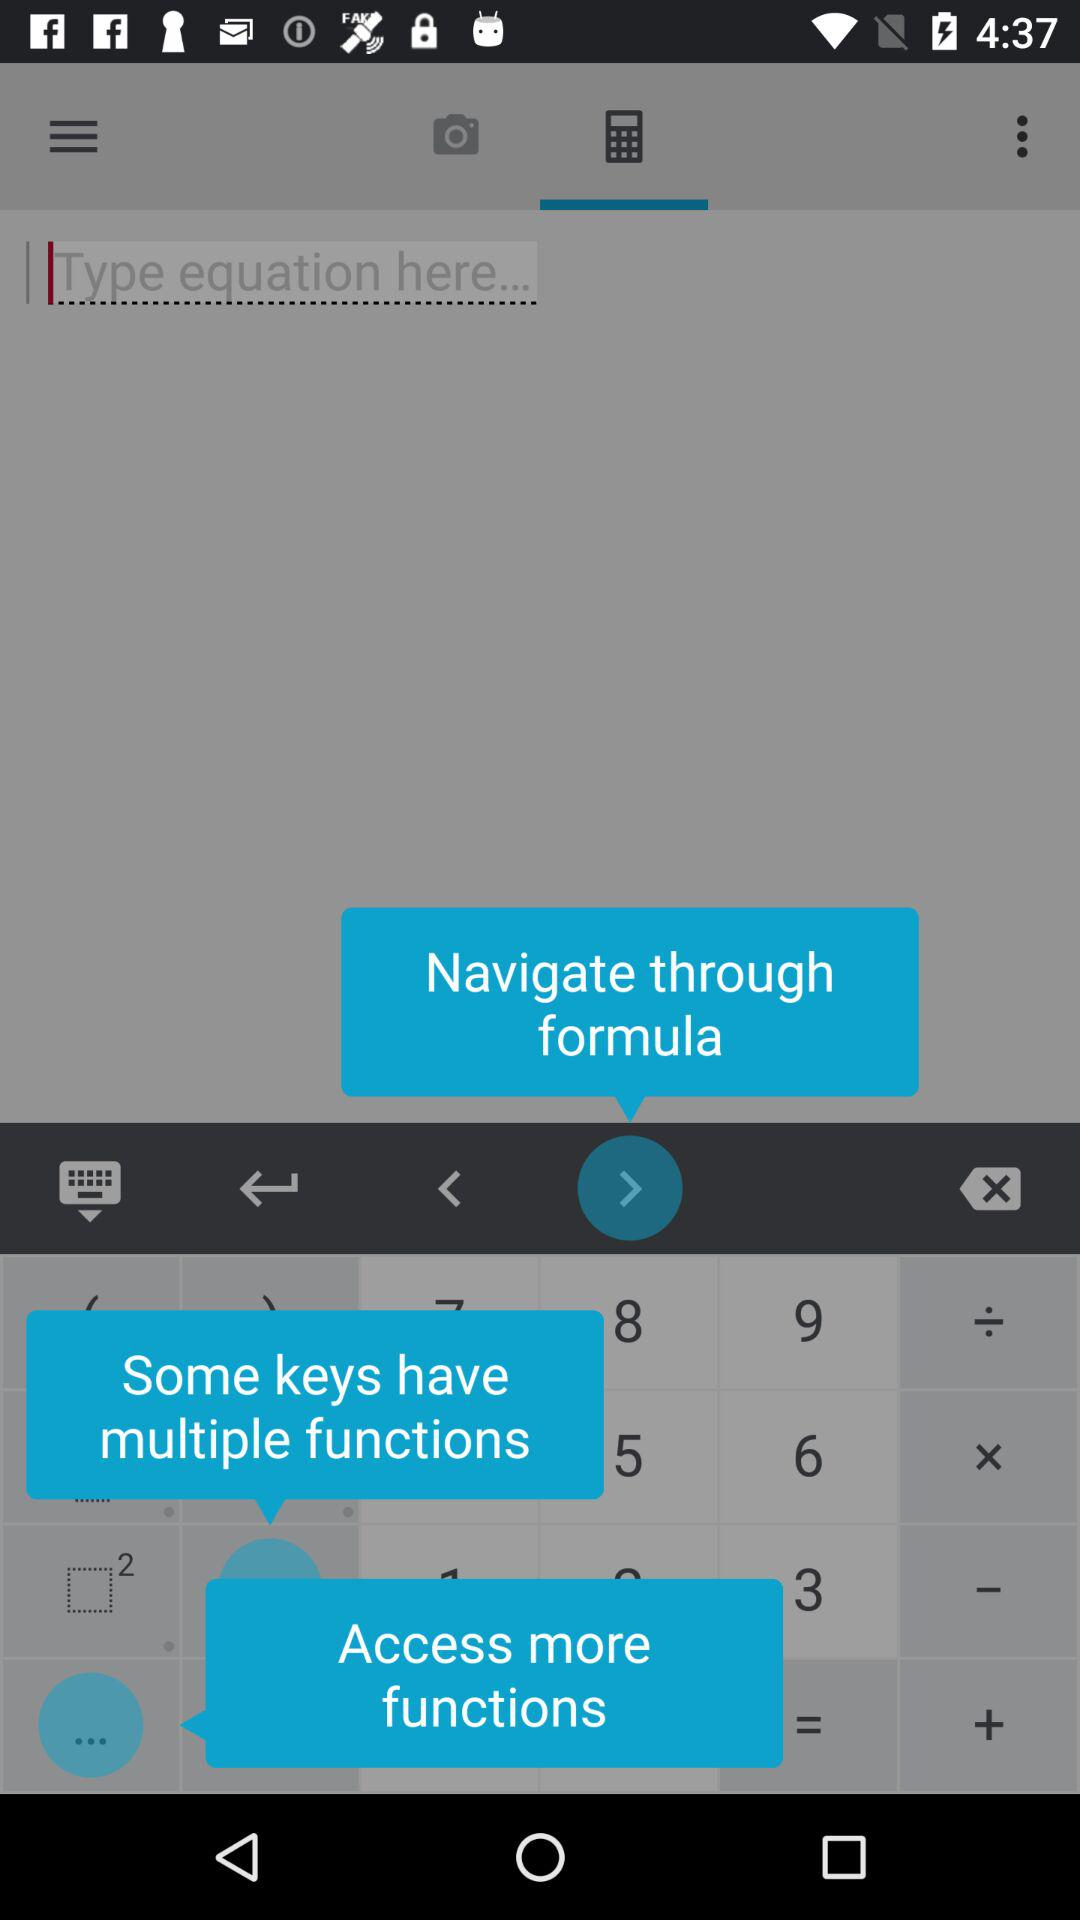Which tab is currently selected? The currently selected tab is "Calculator". 